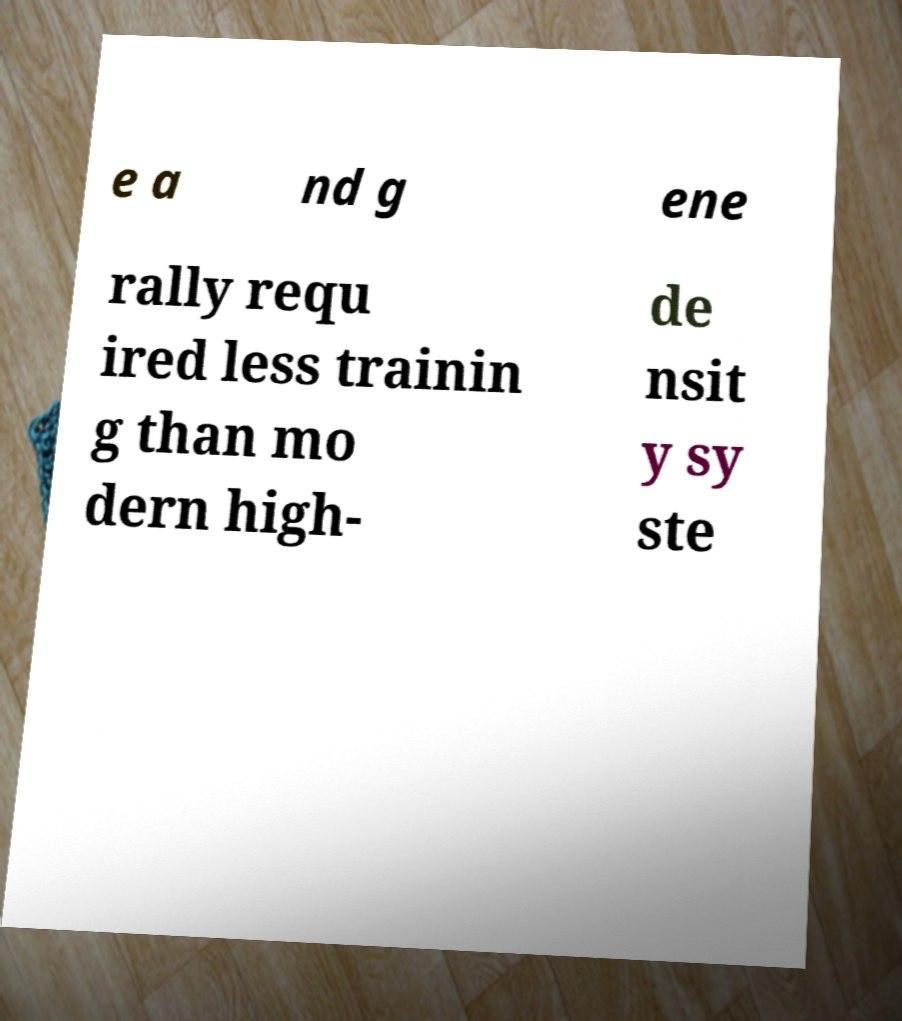For documentation purposes, I need the text within this image transcribed. Could you provide that? e a nd g ene rally requ ired less trainin g than mo dern high- de nsit y sy ste 